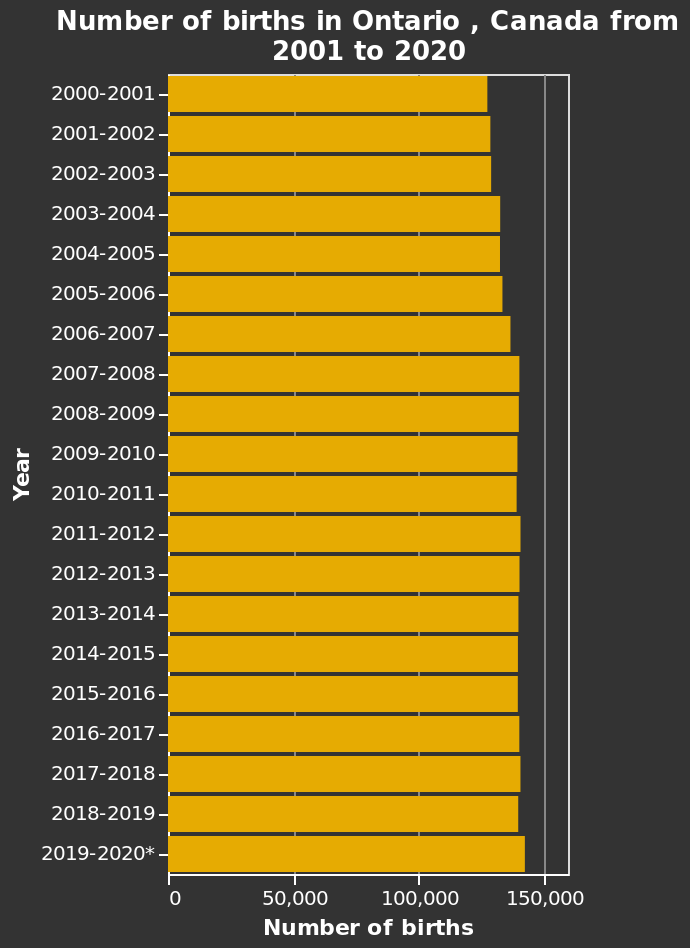<image>
What is the range of the x-axis on the bar chart? The range of the x-axis on the bar chart is from 0 to 150,000. Has the number of births been increasing or decreasing since 2000?  The number of births has been increasing since 2000. What can be said about the number of births since 2000? Since 2000, the number of births has shown a continuous upward trend. What does the y-axis represent on the bar chart? The y-axis on the bar chart represents the years from 2000-2001 to 2019-2020. What is the range of the y-axis on the bar chart? The range of the y-axis on the bar chart is from 2000-2001 to 2019-2020. Has the number of births been decreasing since 2000? No. The number of births has been increasing since 2000. Does the y-axis on the bar chart represent the years from 2000-2001 to 2018-2019? No.The y-axis on the bar chart represents the years from 2000-2001 to 2019-2020. 